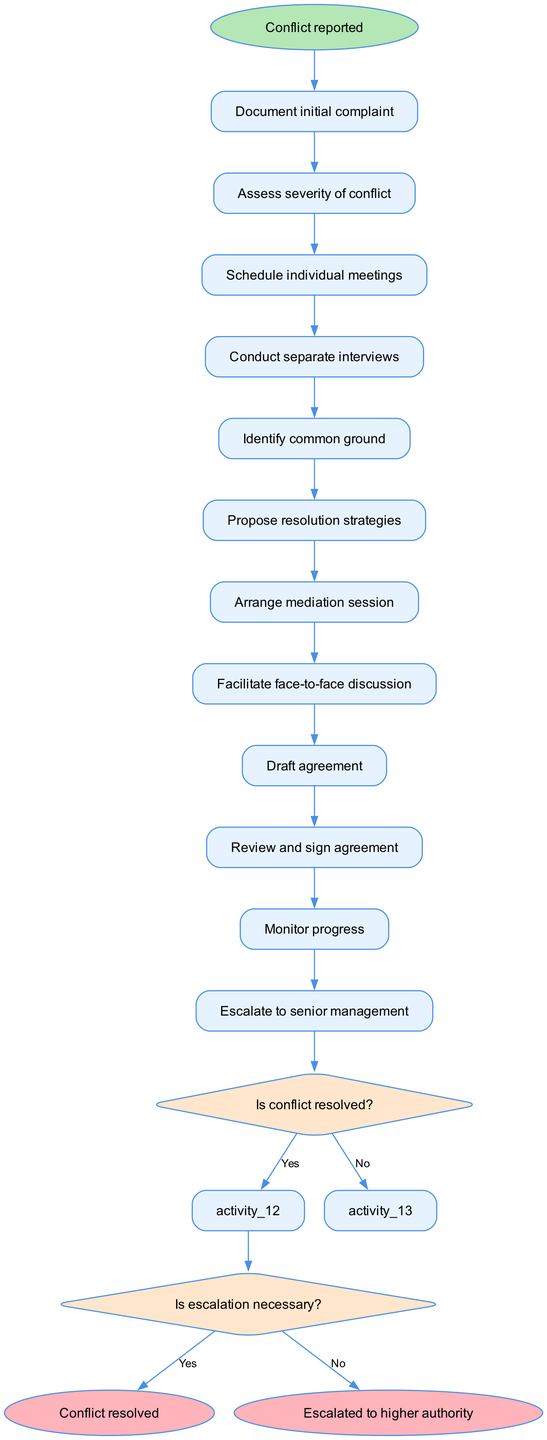What is the first activity in the conflict resolution workflow? The first activity listed in the diagram is "Document initial complaint," which is represented as the first node following the start node.
Answer: Document initial complaint How many total activities are there in the diagram? By counting the activities listed in the "activities" section of the diagram data, there are a total of 12 activities included.
Answer: 12 What decision comes after assessing the severity of conflict? After "Assess severity of conflict," the next step is a decision node that asks "Is conflict resolved?" indicating whether the conflict has been adequately addressed or not.
Answer: Is conflict resolved? What is the consequence of a "No" response at the "Is conflict resolved?" decision? If the answer to "Is conflict resolved?" is "No," the workflow indicates that the next step is to "Schedule individual meetings," leading to further examination of the conflict.
Answer: Schedule individual meetings What are the two possible outcomes if escalation is necessary? The decision node asking "Is escalation necessary?" can lead to two outcomes: either "Escalate to senior management" if the answer is "Yes," or "Facilitate face-to-face discussion" if the answer is "No."
Answer: Escalate to senior management, Facilitate face-to-face discussion Which activities lead to the escalation of the conflict? The escalation occurs only if the decision node "Is escalation necessary?" is answered with "Yes," transitioning from the previous activity directly to "Escalate to senior management."
Answer: Escalate to senior management What is the final outcome of this conflict resolution workflow? The workflow has two possible end points. The final outcomes can be either "Conflict resolved" if the resolution strategies were successful, or "Escalated to higher authority" if further escalation was necessary.
Answer: Conflict resolved, Escalated to higher authority How many decision points are present in the diagram? There are two decision points included in the workflow, specifically after the activities of assessing conflict resolution and determining the necessity for escalation.
Answer: 2 What activity follows the decision "Is escalation necessary?" if the answer is "No"? If the answer is "No" to the escalation decision, the workflow continues with the activity "Facilitate face-to-face discussion" as the next step in resolving the conflict.
Answer: Facilitate face-to-face discussion 